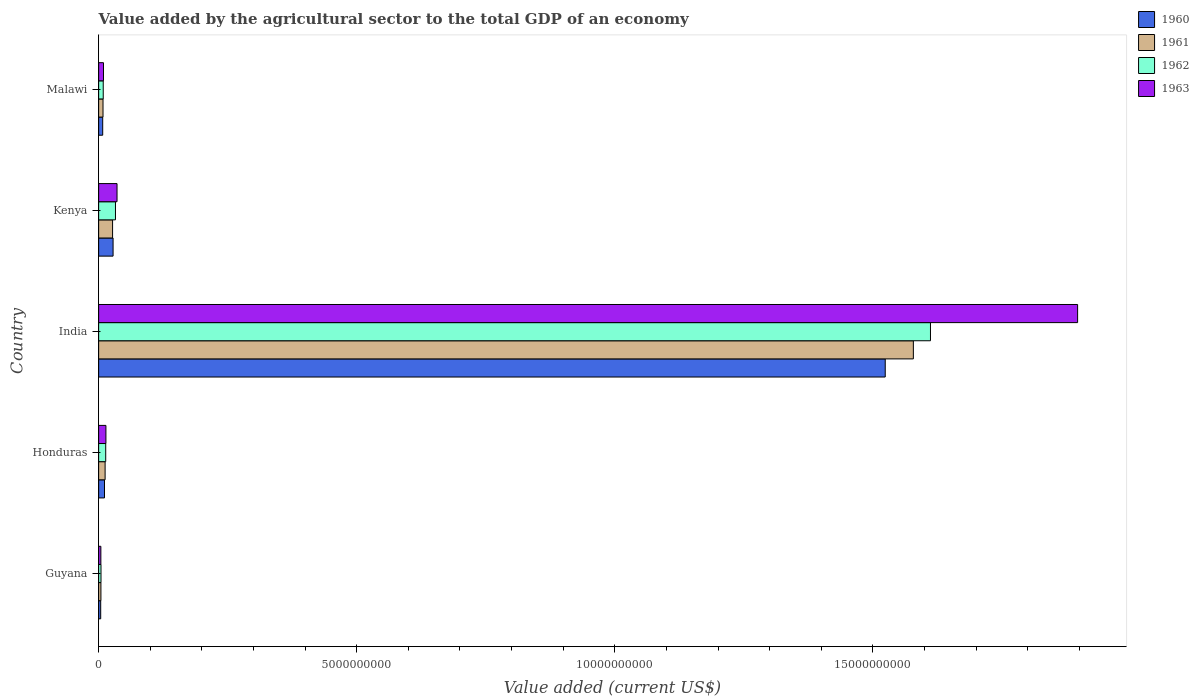How many groups of bars are there?
Make the answer very short. 5. Are the number of bars per tick equal to the number of legend labels?
Provide a succinct answer. Yes. How many bars are there on the 4th tick from the top?
Offer a terse response. 4. What is the label of the 5th group of bars from the top?
Your response must be concise. Guyana. In how many cases, is the number of bars for a given country not equal to the number of legend labels?
Provide a succinct answer. 0. What is the value added by the agricultural sector to the total GDP in 1962 in Guyana?
Your answer should be very brief. 4.57e+07. Across all countries, what is the maximum value added by the agricultural sector to the total GDP in 1961?
Your answer should be very brief. 1.58e+1. Across all countries, what is the minimum value added by the agricultural sector to the total GDP in 1963?
Make the answer very short. 4.30e+07. In which country was the value added by the agricultural sector to the total GDP in 1961 minimum?
Provide a short and direct response. Guyana. What is the total value added by the agricultural sector to the total GDP in 1963 in the graph?
Provide a succinct answer. 1.96e+1. What is the difference between the value added by the agricultural sector to the total GDP in 1961 in India and that in Malawi?
Offer a very short reply. 1.57e+1. What is the difference between the value added by the agricultural sector to the total GDP in 1962 in India and the value added by the agricultural sector to the total GDP in 1960 in Honduras?
Your answer should be compact. 1.60e+1. What is the average value added by the agricultural sector to the total GDP in 1961 per country?
Ensure brevity in your answer.  3.26e+09. What is the difference between the value added by the agricultural sector to the total GDP in 1961 and value added by the agricultural sector to the total GDP in 1962 in Honduras?
Your answer should be compact. -1.16e+07. In how many countries, is the value added by the agricultural sector to the total GDP in 1962 greater than 4000000000 US$?
Your response must be concise. 1. What is the ratio of the value added by the agricultural sector to the total GDP in 1961 in Guyana to that in India?
Your response must be concise. 0. Is the difference between the value added by the agricultural sector to the total GDP in 1961 in Guyana and Kenya greater than the difference between the value added by the agricultural sector to the total GDP in 1962 in Guyana and Kenya?
Offer a terse response. Yes. What is the difference between the highest and the second highest value added by the agricultural sector to the total GDP in 1961?
Your answer should be compact. 1.55e+1. What is the difference between the highest and the lowest value added by the agricultural sector to the total GDP in 1961?
Your response must be concise. 1.57e+1. Is it the case that in every country, the sum of the value added by the agricultural sector to the total GDP in 1962 and value added by the agricultural sector to the total GDP in 1960 is greater than the sum of value added by the agricultural sector to the total GDP in 1963 and value added by the agricultural sector to the total GDP in 1961?
Provide a succinct answer. No. What does the 4th bar from the top in Honduras represents?
Your answer should be compact. 1960. What does the 3rd bar from the bottom in India represents?
Ensure brevity in your answer.  1962. How many bars are there?
Offer a very short reply. 20. Are all the bars in the graph horizontal?
Your answer should be compact. Yes. How many countries are there in the graph?
Offer a terse response. 5. What is the difference between two consecutive major ticks on the X-axis?
Provide a short and direct response. 5.00e+09. Are the values on the major ticks of X-axis written in scientific E-notation?
Provide a short and direct response. No. Does the graph contain grids?
Your answer should be very brief. No. How are the legend labels stacked?
Provide a short and direct response. Vertical. What is the title of the graph?
Your response must be concise. Value added by the agricultural sector to the total GDP of an economy. What is the label or title of the X-axis?
Offer a very short reply. Value added (current US$). What is the label or title of the Y-axis?
Offer a terse response. Country. What is the Value added (current US$) of 1960 in Guyana?
Provide a short and direct response. 4.01e+07. What is the Value added (current US$) in 1961 in Guyana?
Your response must be concise. 4.43e+07. What is the Value added (current US$) in 1962 in Guyana?
Keep it short and to the point. 4.57e+07. What is the Value added (current US$) of 1963 in Guyana?
Make the answer very short. 4.30e+07. What is the Value added (current US$) of 1960 in Honduras?
Your response must be concise. 1.14e+08. What is the Value added (current US$) of 1961 in Honduras?
Make the answer very short. 1.26e+08. What is the Value added (current US$) in 1962 in Honduras?
Provide a succinct answer. 1.37e+08. What is the Value added (current US$) of 1963 in Honduras?
Provide a short and direct response. 1.41e+08. What is the Value added (current US$) in 1960 in India?
Provide a short and direct response. 1.52e+1. What is the Value added (current US$) in 1961 in India?
Your response must be concise. 1.58e+1. What is the Value added (current US$) of 1962 in India?
Keep it short and to the point. 1.61e+1. What is the Value added (current US$) of 1963 in India?
Make the answer very short. 1.90e+1. What is the Value added (current US$) of 1960 in Kenya?
Your response must be concise. 2.80e+08. What is the Value added (current US$) in 1961 in Kenya?
Provide a succinct answer. 2.70e+08. What is the Value added (current US$) in 1962 in Kenya?
Your response must be concise. 3.26e+08. What is the Value added (current US$) in 1963 in Kenya?
Your response must be concise. 3.56e+08. What is the Value added (current US$) of 1960 in Malawi?
Your answer should be very brief. 7.88e+07. What is the Value added (current US$) of 1961 in Malawi?
Provide a short and direct response. 8.48e+07. What is the Value added (current US$) in 1962 in Malawi?
Ensure brevity in your answer.  8.90e+07. What is the Value added (current US$) of 1963 in Malawi?
Make the answer very short. 9.39e+07. Across all countries, what is the maximum Value added (current US$) in 1960?
Your response must be concise. 1.52e+1. Across all countries, what is the maximum Value added (current US$) in 1961?
Your response must be concise. 1.58e+1. Across all countries, what is the maximum Value added (current US$) of 1962?
Keep it short and to the point. 1.61e+1. Across all countries, what is the maximum Value added (current US$) of 1963?
Offer a very short reply. 1.90e+1. Across all countries, what is the minimum Value added (current US$) of 1960?
Your answer should be very brief. 4.01e+07. Across all countries, what is the minimum Value added (current US$) in 1961?
Offer a very short reply. 4.43e+07. Across all countries, what is the minimum Value added (current US$) of 1962?
Keep it short and to the point. 4.57e+07. Across all countries, what is the minimum Value added (current US$) of 1963?
Give a very brief answer. 4.30e+07. What is the total Value added (current US$) in 1960 in the graph?
Make the answer very short. 1.58e+1. What is the total Value added (current US$) in 1961 in the graph?
Your answer should be compact. 1.63e+1. What is the total Value added (current US$) of 1962 in the graph?
Provide a short and direct response. 1.67e+1. What is the total Value added (current US$) in 1963 in the graph?
Your answer should be very brief. 1.96e+1. What is the difference between the Value added (current US$) of 1960 in Guyana and that in Honduras?
Make the answer very short. -7.34e+07. What is the difference between the Value added (current US$) in 1961 in Guyana and that in Honduras?
Keep it short and to the point. -8.13e+07. What is the difference between the Value added (current US$) in 1962 in Guyana and that in Honduras?
Give a very brief answer. -9.15e+07. What is the difference between the Value added (current US$) in 1963 in Guyana and that in Honduras?
Ensure brevity in your answer.  -9.82e+07. What is the difference between the Value added (current US$) in 1960 in Guyana and that in India?
Ensure brevity in your answer.  -1.52e+1. What is the difference between the Value added (current US$) in 1961 in Guyana and that in India?
Your response must be concise. -1.57e+1. What is the difference between the Value added (current US$) of 1962 in Guyana and that in India?
Your answer should be compact. -1.61e+1. What is the difference between the Value added (current US$) of 1963 in Guyana and that in India?
Your response must be concise. -1.89e+1. What is the difference between the Value added (current US$) of 1960 in Guyana and that in Kenya?
Offer a terse response. -2.40e+08. What is the difference between the Value added (current US$) of 1961 in Guyana and that in Kenya?
Provide a succinct answer. -2.26e+08. What is the difference between the Value added (current US$) in 1962 in Guyana and that in Kenya?
Your answer should be very brief. -2.80e+08. What is the difference between the Value added (current US$) in 1963 in Guyana and that in Kenya?
Provide a succinct answer. -3.13e+08. What is the difference between the Value added (current US$) in 1960 in Guyana and that in Malawi?
Make the answer very short. -3.87e+07. What is the difference between the Value added (current US$) of 1961 in Guyana and that in Malawi?
Keep it short and to the point. -4.05e+07. What is the difference between the Value added (current US$) in 1962 in Guyana and that in Malawi?
Provide a succinct answer. -4.33e+07. What is the difference between the Value added (current US$) in 1963 in Guyana and that in Malawi?
Provide a short and direct response. -5.09e+07. What is the difference between the Value added (current US$) in 1960 in Honduras and that in India?
Ensure brevity in your answer.  -1.51e+1. What is the difference between the Value added (current US$) in 1961 in Honduras and that in India?
Keep it short and to the point. -1.57e+1. What is the difference between the Value added (current US$) of 1962 in Honduras and that in India?
Provide a short and direct response. -1.60e+1. What is the difference between the Value added (current US$) in 1963 in Honduras and that in India?
Provide a succinct answer. -1.88e+1. What is the difference between the Value added (current US$) of 1960 in Honduras and that in Kenya?
Your response must be concise. -1.66e+08. What is the difference between the Value added (current US$) in 1961 in Honduras and that in Kenya?
Offer a very short reply. -1.45e+08. What is the difference between the Value added (current US$) of 1962 in Honduras and that in Kenya?
Provide a succinct answer. -1.89e+08. What is the difference between the Value added (current US$) in 1963 in Honduras and that in Kenya?
Provide a succinct answer. -2.15e+08. What is the difference between the Value added (current US$) of 1960 in Honduras and that in Malawi?
Give a very brief answer. 3.47e+07. What is the difference between the Value added (current US$) of 1961 in Honduras and that in Malawi?
Keep it short and to the point. 4.08e+07. What is the difference between the Value added (current US$) in 1962 in Honduras and that in Malawi?
Provide a succinct answer. 4.82e+07. What is the difference between the Value added (current US$) of 1963 in Honduras and that in Malawi?
Provide a short and direct response. 4.72e+07. What is the difference between the Value added (current US$) of 1960 in India and that in Kenya?
Provide a succinct answer. 1.50e+1. What is the difference between the Value added (current US$) in 1961 in India and that in Kenya?
Ensure brevity in your answer.  1.55e+1. What is the difference between the Value added (current US$) of 1962 in India and that in Kenya?
Provide a short and direct response. 1.58e+1. What is the difference between the Value added (current US$) of 1963 in India and that in Kenya?
Ensure brevity in your answer.  1.86e+1. What is the difference between the Value added (current US$) of 1960 in India and that in Malawi?
Provide a short and direct response. 1.52e+1. What is the difference between the Value added (current US$) of 1961 in India and that in Malawi?
Your answer should be compact. 1.57e+1. What is the difference between the Value added (current US$) in 1962 in India and that in Malawi?
Offer a terse response. 1.60e+1. What is the difference between the Value added (current US$) in 1963 in India and that in Malawi?
Offer a very short reply. 1.89e+1. What is the difference between the Value added (current US$) in 1960 in Kenya and that in Malawi?
Give a very brief answer. 2.01e+08. What is the difference between the Value added (current US$) in 1961 in Kenya and that in Malawi?
Your answer should be compact. 1.85e+08. What is the difference between the Value added (current US$) in 1962 in Kenya and that in Malawi?
Keep it short and to the point. 2.37e+08. What is the difference between the Value added (current US$) in 1963 in Kenya and that in Malawi?
Make the answer very short. 2.62e+08. What is the difference between the Value added (current US$) in 1960 in Guyana and the Value added (current US$) in 1961 in Honduras?
Provide a succinct answer. -8.55e+07. What is the difference between the Value added (current US$) in 1960 in Guyana and the Value added (current US$) in 1962 in Honduras?
Your answer should be very brief. -9.71e+07. What is the difference between the Value added (current US$) in 1960 in Guyana and the Value added (current US$) in 1963 in Honduras?
Offer a very short reply. -1.01e+08. What is the difference between the Value added (current US$) of 1961 in Guyana and the Value added (current US$) of 1962 in Honduras?
Your answer should be very brief. -9.29e+07. What is the difference between the Value added (current US$) of 1961 in Guyana and the Value added (current US$) of 1963 in Honduras?
Provide a succinct answer. -9.68e+07. What is the difference between the Value added (current US$) of 1962 in Guyana and the Value added (current US$) of 1963 in Honduras?
Your answer should be very brief. -9.54e+07. What is the difference between the Value added (current US$) in 1960 in Guyana and the Value added (current US$) in 1961 in India?
Give a very brief answer. -1.57e+1. What is the difference between the Value added (current US$) in 1960 in Guyana and the Value added (current US$) in 1962 in India?
Provide a short and direct response. -1.61e+1. What is the difference between the Value added (current US$) in 1960 in Guyana and the Value added (current US$) in 1963 in India?
Ensure brevity in your answer.  -1.89e+1. What is the difference between the Value added (current US$) of 1961 in Guyana and the Value added (current US$) of 1962 in India?
Your response must be concise. -1.61e+1. What is the difference between the Value added (current US$) of 1961 in Guyana and the Value added (current US$) of 1963 in India?
Give a very brief answer. -1.89e+1. What is the difference between the Value added (current US$) of 1962 in Guyana and the Value added (current US$) of 1963 in India?
Your response must be concise. -1.89e+1. What is the difference between the Value added (current US$) in 1960 in Guyana and the Value added (current US$) in 1961 in Kenya?
Provide a succinct answer. -2.30e+08. What is the difference between the Value added (current US$) in 1960 in Guyana and the Value added (current US$) in 1962 in Kenya?
Keep it short and to the point. -2.86e+08. What is the difference between the Value added (current US$) of 1960 in Guyana and the Value added (current US$) of 1963 in Kenya?
Provide a succinct answer. -3.16e+08. What is the difference between the Value added (current US$) of 1961 in Guyana and the Value added (current US$) of 1962 in Kenya?
Offer a terse response. -2.82e+08. What is the difference between the Value added (current US$) in 1961 in Guyana and the Value added (current US$) in 1963 in Kenya?
Provide a short and direct response. -3.12e+08. What is the difference between the Value added (current US$) of 1962 in Guyana and the Value added (current US$) of 1963 in Kenya?
Offer a terse response. -3.11e+08. What is the difference between the Value added (current US$) of 1960 in Guyana and the Value added (current US$) of 1961 in Malawi?
Provide a short and direct response. -4.47e+07. What is the difference between the Value added (current US$) in 1960 in Guyana and the Value added (current US$) in 1962 in Malawi?
Ensure brevity in your answer.  -4.89e+07. What is the difference between the Value added (current US$) in 1960 in Guyana and the Value added (current US$) in 1963 in Malawi?
Your response must be concise. -5.38e+07. What is the difference between the Value added (current US$) in 1961 in Guyana and the Value added (current US$) in 1962 in Malawi?
Provide a short and direct response. -4.47e+07. What is the difference between the Value added (current US$) in 1961 in Guyana and the Value added (current US$) in 1963 in Malawi?
Offer a very short reply. -4.96e+07. What is the difference between the Value added (current US$) in 1962 in Guyana and the Value added (current US$) in 1963 in Malawi?
Provide a short and direct response. -4.82e+07. What is the difference between the Value added (current US$) of 1960 in Honduras and the Value added (current US$) of 1961 in India?
Your answer should be compact. -1.57e+1. What is the difference between the Value added (current US$) in 1960 in Honduras and the Value added (current US$) in 1962 in India?
Your answer should be very brief. -1.60e+1. What is the difference between the Value added (current US$) of 1960 in Honduras and the Value added (current US$) of 1963 in India?
Provide a short and direct response. -1.89e+1. What is the difference between the Value added (current US$) in 1961 in Honduras and the Value added (current US$) in 1962 in India?
Offer a very short reply. -1.60e+1. What is the difference between the Value added (current US$) in 1961 in Honduras and the Value added (current US$) in 1963 in India?
Make the answer very short. -1.88e+1. What is the difference between the Value added (current US$) of 1962 in Honduras and the Value added (current US$) of 1963 in India?
Your answer should be very brief. -1.88e+1. What is the difference between the Value added (current US$) of 1960 in Honduras and the Value added (current US$) of 1961 in Kenya?
Ensure brevity in your answer.  -1.57e+08. What is the difference between the Value added (current US$) of 1960 in Honduras and the Value added (current US$) of 1962 in Kenya?
Provide a succinct answer. -2.13e+08. What is the difference between the Value added (current US$) in 1960 in Honduras and the Value added (current US$) in 1963 in Kenya?
Make the answer very short. -2.43e+08. What is the difference between the Value added (current US$) in 1961 in Honduras and the Value added (current US$) in 1962 in Kenya?
Offer a terse response. -2.01e+08. What is the difference between the Value added (current US$) of 1961 in Honduras and the Value added (current US$) of 1963 in Kenya?
Your answer should be compact. -2.31e+08. What is the difference between the Value added (current US$) in 1962 in Honduras and the Value added (current US$) in 1963 in Kenya?
Your response must be concise. -2.19e+08. What is the difference between the Value added (current US$) in 1960 in Honduras and the Value added (current US$) in 1961 in Malawi?
Provide a succinct answer. 2.87e+07. What is the difference between the Value added (current US$) in 1960 in Honduras and the Value added (current US$) in 1962 in Malawi?
Offer a terse response. 2.45e+07. What is the difference between the Value added (current US$) in 1960 in Honduras and the Value added (current US$) in 1963 in Malawi?
Your answer should be compact. 1.96e+07. What is the difference between the Value added (current US$) of 1961 in Honduras and the Value added (current US$) of 1962 in Malawi?
Give a very brief answer. 3.66e+07. What is the difference between the Value added (current US$) of 1961 in Honduras and the Value added (current US$) of 1963 in Malawi?
Provide a succinct answer. 3.17e+07. What is the difference between the Value added (current US$) in 1962 in Honduras and the Value added (current US$) in 1963 in Malawi?
Provide a succinct answer. 4.33e+07. What is the difference between the Value added (current US$) in 1960 in India and the Value added (current US$) in 1961 in Kenya?
Your response must be concise. 1.50e+1. What is the difference between the Value added (current US$) in 1960 in India and the Value added (current US$) in 1962 in Kenya?
Offer a terse response. 1.49e+1. What is the difference between the Value added (current US$) in 1960 in India and the Value added (current US$) in 1963 in Kenya?
Provide a succinct answer. 1.49e+1. What is the difference between the Value added (current US$) of 1961 in India and the Value added (current US$) of 1962 in Kenya?
Ensure brevity in your answer.  1.55e+1. What is the difference between the Value added (current US$) in 1961 in India and the Value added (current US$) in 1963 in Kenya?
Ensure brevity in your answer.  1.54e+1. What is the difference between the Value added (current US$) of 1962 in India and the Value added (current US$) of 1963 in Kenya?
Your response must be concise. 1.58e+1. What is the difference between the Value added (current US$) of 1960 in India and the Value added (current US$) of 1961 in Malawi?
Give a very brief answer. 1.52e+1. What is the difference between the Value added (current US$) of 1960 in India and the Value added (current US$) of 1962 in Malawi?
Your response must be concise. 1.51e+1. What is the difference between the Value added (current US$) in 1960 in India and the Value added (current US$) in 1963 in Malawi?
Your response must be concise. 1.51e+1. What is the difference between the Value added (current US$) in 1961 in India and the Value added (current US$) in 1962 in Malawi?
Your answer should be compact. 1.57e+1. What is the difference between the Value added (current US$) of 1961 in India and the Value added (current US$) of 1963 in Malawi?
Your response must be concise. 1.57e+1. What is the difference between the Value added (current US$) in 1962 in India and the Value added (current US$) in 1963 in Malawi?
Offer a terse response. 1.60e+1. What is the difference between the Value added (current US$) of 1960 in Kenya and the Value added (current US$) of 1961 in Malawi?
Your response must be concise. 1.95e+08. What is the difference between the Value added (current US$) in 1960 in Kenya and the Value added (current US$) in 1962 in Malawi?
Provide a short and direct response. 1.91e+08. What is the difference between the Value added (current US$) in 1960 in Kenya and the Value added (current US$) in 1963 in Malawi?
Make the answer very short. 1.86e+08. What is the difference between the Value added (current US$) of 1961 in Kenya and the Value added (current US$) of 1962 in Malawi?
Make the answer very short. 1.81e+08. What is the difference between the Value added (current US$) in 1961 in Kenya and the Value added (current US$) in 1963 in Malawi?
Provide a short and direct response. 1.76e+08. What is the difference between the Value added (current US$) in 1962 in Kenya and the Value added (current US$) in 1963 in Malawi?
Offer a very short reply. 2.32e+08. What is the average Value added (current US$) of 1960 per country?
Provide a succinct answer. 3.15e+09. What is the average Value added (current US$) in 1961 per country?
Make the answer very short. 3.26e+09. What is the average Value added (current US$) in 1962 per country?
Your response must be concise. 3.34e+09. What is the average Value added (current US$) of 1963 per country?
Your response must be concise. 3.92e+09. What is the difference between the Value added (current US$) of 1960 and Value added (current US$) of 1961 in Guyana?
Your answer should be very brief. -4.20e+06. What is the difference between the Value added (current US$) in 1960 and Value added (current US$) in 1962 in Guyana?
Your answer should be compact. -5.60e+06. What is the difference between the Value added (current US$) of 1960 and Value added (current US$) of 1963 in Guyana?
Make the answer very short. -2.86e+06. What is the difference between the Value added (current US$) in 1961 and Value added (current US$) in 1962 in Guyana?
Give a very brief answer. -1.40e+06. What is the difference between the Value added (current US$) in 1961 and Value added (current US$) in 1963 in Guyana?
Give a very brief answer. 1.34e+06. What is the difference between the Value added (current US$) of 1962 and Value added (current US$) of 1963 in Guyana?
Provide a succinct answer. 2.74e+06. What is the difference between the Value added (current US$) in 1960 and Value added (current US$) in 1961 in Honduras?
Provide a succinct answer. -1.21e+07. What is the difference between the Value added (current US$) in 1960 and Value added (current US$) in 1962 in Honduras?
Keep it short and to the point. -2.38e+07. What is the difference between the Value added (current US$) of 1960 and Value added (current US$) of 1963 in Honduras?
Make the answer very short. -2.76e+07. What is the difference between the Value added (current US$) in 1961 and Value added (current US$) in 1962 in Honduras?
Provide a short and direct response. -1.16e+07. What is the difference between the Value added (current US$) in 1961 and Value added (current US$) in 1963 in Honduras?
Keep it short and to the point. -1.56e+07. What is the difference between the Value added (current US$) in 1962 and Value added (current US$) in 1963 in Honduras?
Offer a terse response. -3.90e+06. What is the difference between the Value added (current US$) of 1960 and Value added (current US$) of 1961 in India?
Make the answer very short. -5.45e+08. What is the difference between the Value added (current US$) of 1960 and Value added (current US$) of 1962 in India?
Your response must be concise. -8.76e+08. What is the difference between the Value added (current US$) in 1960 and Value added (current US$) in 1963 in India?
Offer a very short reply. -3.73e+09. What is the difference between the Value added (current US$) in 1961 and Value added (current US$) in 1962 in India?
Your answer should be compact. -3.32e+08. What is the difference between the Value added (current US$) in 1961 and Value added (current US$) in 1963 in India?
Your answer should be very brief. -3.18e+09. What is the difference between the Value added (current US$) of 1962 and Value added (current US$) of 1963 in India?
Your answer should be very brief. -2.85e+09. What is the difference between the Value added (current US$) of 1960 and Value added (current US$) of 1961 in Kenya?
Make the answer very short. 9.51e+06. What is the difference between the Value added (current US$) of 1960 and Value added (current US$) of 1962 in Kenya?
Provide a succinct answer. -4.65e+07. What is the difference between the Value added (current US$) in 1960 and Value added (current US$) in 1963 in Kenya?
Provide a short and direct response. -7.66e+07. What is the difference between the Value added (current US$) in 1961 and Value added (current US$) in 1962 in Kenya?
Your answer should be compact. -5.60e+07. What is the difference between the Value added (current US$) of 1961 and Value added (current US$) of 1963 in Kenya?
Ensure brevity in your answer.  -8.61e+07. What is the difference between the Value added (current US$) of 1962 and Value added (current US$) of 1963 in Kenya?
Your answer should be compact. -3.01e+07. What is the difference between the Value added (current US$) in 1960 and Value added (current US$) in 1961 in Malawi?
Your answer should be compact. -6.02e+06. What is the difference between the Value added (current US$) of 1960 and Value added (current US$) of 1962 in Malawi?
Offer a terse response. -1.02e+07. What is the difference between the Value added (current US$) in 1960 and Value added (current US$) in 1963 in Malawi?
Make the answer very short. -1.51e+07. What is the difference between the Value added (current US$) in 1961 and Value added (current US$) in 1962 in Malawi?
Your answer should be very brief. -4.20e+06. What is the difference between the Value added (current US$) in 1961 and Value added (current US$) in 1963 in Malawi?
Make the answer very short. -9.10e+06. What is the difference between the Value added (current US$) of 1962 and Value added (current US$) of 1963 in Malawi?
Your answer should be very brief. -4.90e+06. What is the ratio of the Value added (current US$) of 1960 in Guyana to that in Honduras?
Make the answer very short. 0.35. What is the ratio of the Value added (current US$) in 1961 in Guyana to that in Honduras?
Provide a succinct answer. 0.35. What is the ratio of the Value added (current US$) in 1962 in Guyana to that in Honduras?
Keep it short and to the point. 0.33. What is the ratio of the Value added (current US$) of 1963 in Guyana to that in Honduras?
Your answer should be very brief. 0.3. What is the ratio of the Value added (current US$) of 1960 in Guyana to that in India?
Offer a terse response. 0. What is the ratio of the Value added (current US$) in 1961 in Guyana to that in India?
Offer a very short reply. 0. What is the ratio of the Value added (current US$) of 1962 in Guyana to that in India?
Provide a short and direct response. 0. What is the ratio of the Value added (current US$) in 1963 in Guyana to that in India?
Offer a terse response. 0. What is the ratio of the Value added (current US$) in 1960 in Guyana to that in Kenya?
Give a very brief answer. 0.14. What is the ratio of the Value added (current US$) of 1961 in Guyana to that in Kenya?
Make the answer very short. 0.16. What is the ratio of the Value added (current US$) in 1962 in Guyana to that in Kenya?
Your response must be concise. 0.14. What is the ratio of the Value added (current US$) of 1963 in Guyana to that in Kenya?
Give a very brief answer. 0.12. What is the ratio of the Value added (current US$) of 1960 in Guyana to that in Malawi?
Make the answer very short. 0.51. What is the ratio of the Value added (current US$) of 1961 in Guyana to that in Malawi?
Make the answer very short. 0.52. What is the ratio of the Value added (current US$) in 1962 in Guyana to that in Malawi?
Your response must be concise. 0.51. What is the ratio of the Value added (current US$) in 1963 in Guyana to that in Malawi?
Provide a short and direct response. 0.46. What is the ratio of the Value added (current US$) of 1960 in Honduras to that in India?
Ensure brevity in your answer.  0.01. What is the ratio of the Value added (current US$) of 1961 in Honduras to that in India?
Provide a short and direct response. 0.01. What is the ratio of the Value added (current US$) in 1962 in Honduras to that in India?
Provide a short and direct response. 0.01. What is the ratio of the Value added (current US$) of 1963 in Honduras to that in India?
Keep it short and to the point. 0.01. What is the ratio of the Value added (current US$) of 1960 in Honduras to that in Kenya?
Offer a terse response. 0.41. What is the ratio of the Value added (current US$) of 1961 in Honduras to that in Kenya?
Offer a very short reply. 0.46. What is the ratio of the Value added (current US$) of 1962 in Honduras to that in Kenya?
Offer a very short reply. 0.42. What is the ratio of the Value added (current US$) in 1963 in Honduras to that in Kenya?
Keep it short and to the point. 0.4. What is the ratio of the Value added (current US$) in 1960 in Honduras to that in Malawi?
Offer a very short reply. 1.44. What is the ratio of the Value added (current US$) of 1961 in Honduras to that in Malawi?
Give a very brief answer. 1.48. What is the ratio of the Value added (current US$) in 1962 in Honduras to that in Malawi?
Your answer should be very brief. 1.54. What is the ratio of the Value added (current US$) in 1963 in Honduras to that in Malawi?
Offer a very short reply. 1.5. What is the ratio of the Value added (current US$) of 1960 in India to that in Kenya?
Offer a very short reply. 54.48. What is the ratio of the Value added (current US$) in 1961 in India to that in Kenya?
Offer a terse response. 58.42. What is the ratio of the Value added (current US$) in 1962 in India to that in Kenya?
Provide a short and direct response. 49.4. What is the ratio of the Value added (current US$) in 1963 in India to that in Kenya?
Keep it short and to the point. 53.23. What is the ratio of the Value added (current US$) in 1960 in India to that in Malawi?
Your answer should be compact. 193.33. What is the ratio of the Value added (current US$) of 1961 in India to that in Malawi?
Provide a succinct answer. 186.04. What is the ratio of the Value added (current US$) in 1962 in India to that in Malawi?
Your answer should be compact. 180.99. What is the ratio of the Value added (current US$) in 1963 in India to that in Malawi?
Provide a short and direct response. 201.89. What is the ratio of the Value added (current US$) of 1960 in Kenya to that in Malawi?
Provide a short and direct response. 3.55. What is the ratio of the Value added (current US$) of 1961 in Kenya to that in Malawi?
Provide a succinct answer. 3.18. What is the ratio of the Value added (current US$) of 1962 in Kenya to that in Malawi?
Your answer should be very brief. 3.66. What is the ratio of the Value added (current US$) of 1963 in Kenya to that in Malawi?
Give a very brief answer. 3.79. What is the difference between the highest and the second highest Value added (current US$) of 1960?
Your answer should be very brief. 1.50e+1. What is the difference between the highest and the second highest Value added (current US$) of 1961?
Give a very brief answer. 1.55e+1. What is the difference between the highest and the second highest Value added (current US$) in 1962?
Your answer should be very brief. 1.58e+1. What is the difference between the highest and the second highest Value added (current US$) of 1963?
Your answer should be compact. 1.86e+1. What is the difference between the highest and the lowest Value added (current US$) of 1960?
Ensure brevity in your answer.  1.52e+1. What is the difference between the highest and the lowest Value added (current US$) of 1961?
Keep it short and to the point. 1.57e+1. What is the difference between the highest and the lowest Value added (current US$) of 1962?
Your answer should be very brief. 1.61e+1. What is the difference between the highest and the lowest Value added (current US$) in 1963?
Provide a short and direct response. 1.89e+1. 